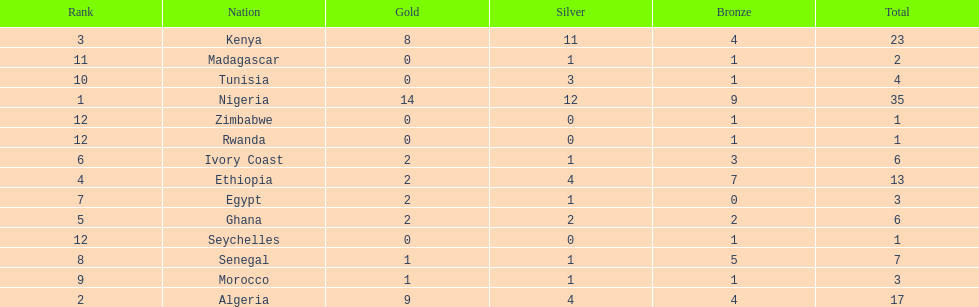The team with the most gold medals Nigeria. Can you give me this table as a dict? {'header': ['Rank', 'Nation', 'Gold', 'Silver', 'Bronze', 'Total'], 'rows': [['3', 'Kenya', '8', '11', '4', '23'], ['11', 'Madagascar', '0', '1', '1', '2'], ['10', 'Tunisia', '0', '3', '1', '4'], ['1', 'Nigeria', '14', '12', '9', '35'], ['12', 'Zimbabwe', '0', '0', '1', '1'], ['12', 'Rwanda', '0', '0', '1', '1'], ['6', 'Ivory Coast', '2', '1', '3', '6'], ['4', 'Ethiopia', '2', '4', '7', '13'], ['7', 'Egypt', '2', '1', '0', '3'], ['5', 'Ghana', '2', '2', '2', '6'], ['12', 'Seychelles', '0', '0', '1', '1'], ['8', 'Senegal', '1', '1', '5', '7'], ['9', 'Morocco', '1', '1', '1', '3'], ['2', 'Algeria', '9', '4', '4', '17']]} 